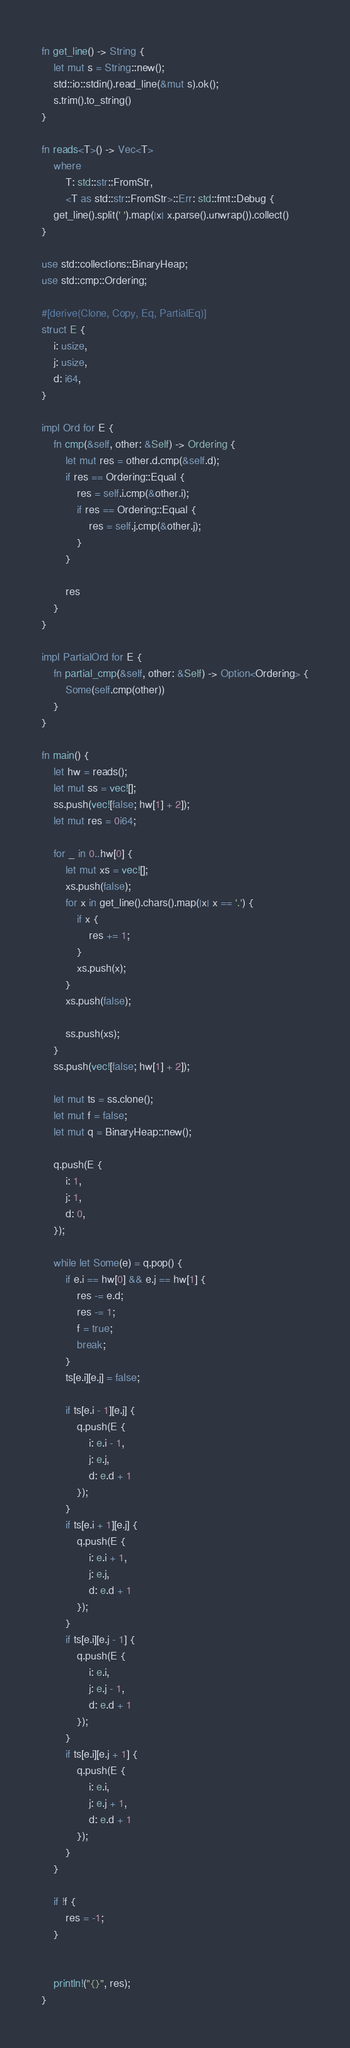<code> <loc_0><loc_0><loc_500><loc_500><_Rust_>fn get_line() -> String {
    let mut s = String::new();
    std::io::stdin().read_line(&mut s).ok();
    s.trim().to_string()
}

fn reads<T>() -> Vec<T>
    where
        T: std::str::FromStr,
        <T as std::str::FromStr>::Err: std::fmt::Debug {
    get_line().split(' ').map(|x| x.parse().unwrap()).collect()
}

use std::collections::BinaryHeap;
use std::cmp::Ordering;

#[derive(Clone, Copy, Eq, PartialEq)]
struct E {
    i: usize,
    j: usize,
    d: i64,
}

impl Ord for E {
    fn cmp(&self, other: &Self) -> Ordering {
        let mut res = other.d.cmp(&self.d);
        if res == Ordering::Equal {
            res = self.i.cmp(&other.i);
            if res == Ordering::Equal {
                res = self.j.cmp(&other.j);
            }
        }

        res
    }
}

impl PartialOrd for E {
    fn partial_cmp(&self, other: &Self) -> Option<Ordering> {
        Some(self.cmp(other))
    }
}

fn main() {
    let hw = reads();
    let mut ss = vec![];
    ss.push(vec![false; hw[1] + 2]);
    let mut res = 0i64;

    for _ in 0..hw[0] {
        let mut xs = vec![];
        xs.push(false);
        for x in get_line().chars().map(|x| x == '.') {
            if x {
                res += 1;
            }
            xs.push(x);
        }
        xs.push(false);

        ss.push(xs);
    }
    ss.push(vec![false; hw[1] + 2]);

    let mut ts = ss.clone();
    let mut f = false;
    let mut q = BinaryHeap::new();
    
    q.push(E {
        i: 1,
        j: 1,
        d: 0,
    });

    while let Some(e) = q.pop() {
        if e.i == hw[0] && e.j == hw[1] {
            res -= e.d;
            res -= 1;
            f = true;
            break;
        }
        ts[e.i][e.j] = false;

        if ts[e.i - 1][e.j] {
            q.push(E {
                i: e.i - 1,
                j: e.j,
                d: e.d + 1
            });
        }
        if ts[e.i + 1][e.j] {
            q.push(E {
                i: e.i + 1,
                j: e.j,
                d: e.d + 1
            });
        }
        if ts[e.i][e.j - 1] {
            q.push(E {
                i: e.i,
                j: e.j - 1,
                d: e.d + 1
            });
        }
        if ts[e.i][e.j + 1] {
            q.push(E {
                i: e.i,
                j: e.j + 1,
                d: e.d + 1
            });
        }
    }

    if !f {
        res = -1;
    }
    

    println!("{}", res);
}</code> 